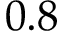Convert formula to latex. <formula><loc_0><loc_0><loc_500><loc_500>0 . 8</formula> 